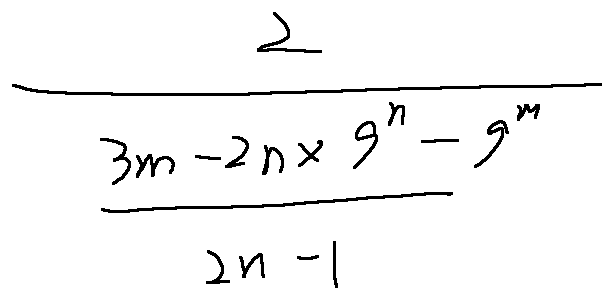Convert formula to latex. <formula><loc_0><loc_0><loc_500><loc_500>\frac { 2 } { \frac { 3 m - 2 n \times 9 ^ { n } - 9 ^ { m } } { 2 n - 1 } }</formula> 